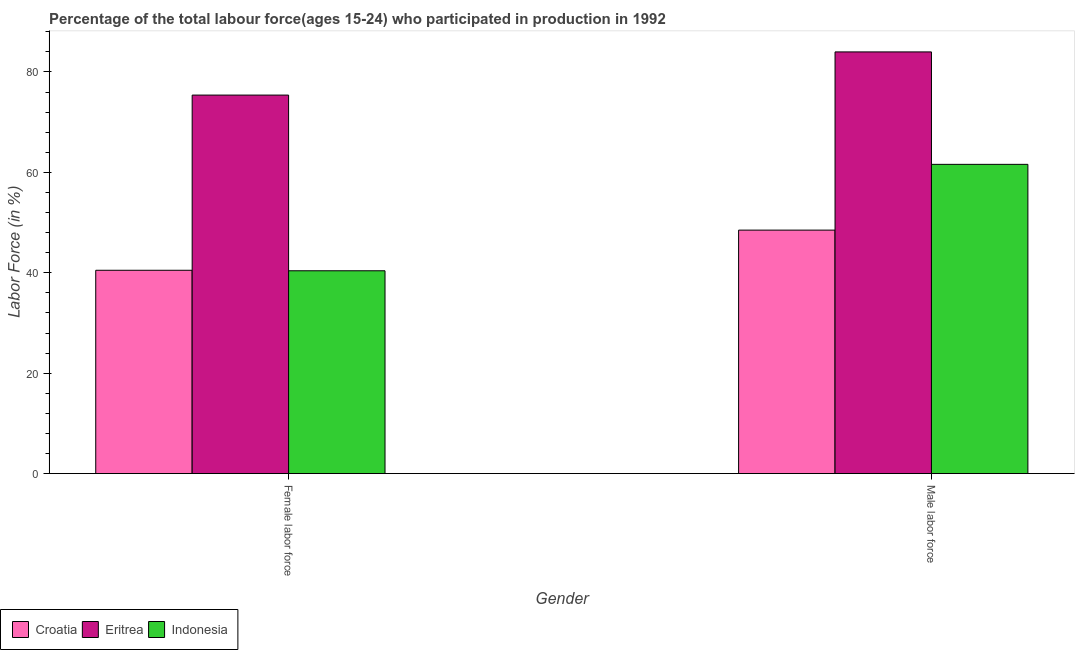How many different coloured bars are there?
Offer a terse response. 3. How many groups of bars are there?
Your answer should be compact. 2. Are the number of bars on each tick of the X-axis equal?
Provide a short and direct response. Yes. How many bars are there on the 2nd tick from the left?
Provide a short and direct response. 3. What is the label of the 1st group of bars from the left?
Provide a succinct answer. Female labor force. What is the percentage of female labor force in Eritrea?
Make the answer very short. 75.4. Across all countries, what is the minimum percentage of female labor force?
Give a very brief answer. 40.4. In which country was the percentage of male labour force maximum?
Give a very brief answer. Eritrea. In which country was the percentage of male labour force minimum?
Make the answer very short. Croatia. What is the total percentage of female labor force in the graph?
Ensure brevity in your answer.  156.3. What is the difference between the percentage of male labour force in Croatia and that in Eritrea?
Offer a very short reply. -35.5. What is the difference between the percentage of female labor force in Eritrea and the percentage of male labour force in Croatia?
Offer a terse response. 26.9. What is the average percentage of female labor force per country?
Provide a short and direct response. 52.1. What is the difference between the percentage of female labor force and percentage of male labour force in Indonesia?
Keep it short and to the point. -21.2. What is the ratio of the percentage of male labour force in Croatia to that in Indonesia?
Offer a terse response. 0.79. Is the percentage of female labor force in Croatia less than that in Indonesia?
Ensure brevity in your answer.  No. In how many countries, is the percentage of female labor force greater than the average percentage of female labor force taken over all countries?
Provide a succinct answer. 1. What does the 2nd bar from the left in Male labor force represents?
Provide a succinct answer. Eritrea. What does the 3rd bar from the right in Female labor force represents?
Make the answer very short. Croatia. How many countries are there in the graph?
Your answer should be very brief. 3. What is the difference between two consecutive major ticks on the Y-axis?
Offer a very short reply. 20. Does the graph contain grids?
Make the answer very short. No. How many legend labels are there?
Make the answer very short. 3. How are the legend labels stacked?
Your answer should be compact. Horizontal. What is the title of the graph?
Your response must be concise. Percentage of the total labour force(ages 15-24) who participated in production in 1992. Does "South Asia" appear as one of the legend labels in the graph?
Provide a succinct answer. No. What is the label or title of the X-axis?
Give a very brief answer. Gender. What is the label or title of the Y-axis?
Keep it short and to the point. Labor Force (in %). What is the Labor Force (in %) in Croatia in Female labor force?
Give a very brief answer. 40.5. What is the Labor Force (in %) of Eritrea in Female labor force?
Your answer should be compact. 75.4. What is the Labor Force (in %) in Indonesia in Female labor force?
Provide a succinct answer. 40.4. What is the Labor Force (in %) in Croatia in Male labor force?
Your answer should be compact. 48.5. What is the Labor Force (in %) of Indonesia in Male labor force?
Offer a terse response. 61.6. Across all Gender, what is the maximum Labor Force (in %) of Croatia?
Your response must be concise. 48.5. Across all Gender, what is the maximum Labor Force (in %) in Indonesia?
Your response must be concise. 61.6. Across all Gender, what is the minimum Labor Force (in %) of Croatia?
Provide a short and direct response. 40.5. Across all Gender, what is the minimum Labor Force (in %) in Eritrea?
Make the answer very short. 75.4. Across all Gender, what is the minimum Labor Force (in %) of Indonesia?
Offer a terse response. 40.4. What is the total Labor Force (in %) in Croatia in the graph?
Make the answer very short. 89. What is the total Labor Force (in %) of Eritrea in the graph?
Keep it short and to the point. 159.4. What is the total Labor Force (in %) of Indonesia in the graph?
Keep it short and to the point. 102. What is the difference between the Labor Force (in %) of Indonesia in Female labor force and that in Male labor force?
Make the answer very short. -21.2. What is the difference between the Labor Force (in %) in Croatia in Female labor force and the Labor Force (in %) in Eritrea in Male labor force?
Ensure brevity in your answer.  -43.5. What is the difference between the Labor Force (in %) in Croatia in Female labor force and the Labor Force (in %) in Indonesia in Male labor force?
Offer a very short reply. -21.1. What is the average Labor Force (in %) of Croatia per Gender?
Provide a short and direct response. 44.5. What is the average Labor Force (in %) of Eritrea per Gender?
Offer a terse response. 79.7. What is the difference between the Labor Force (in %) of Croatia and Labor Force (in %) of Eritrea in Female labor force?
Provide a short and direct response. -34.9. What is the difference between the Labor Force (in %) in Croatia and Labor Force (in %) in Eritrea in Male labor force?
Your answer should be very brief. -35.5. What is the difference between the Labor Force (in %) of Croatia and Labor Force (in %) of Indonesia in Male labor force?
Make the answer very short. -13.1. What is the difference between the Labor Force (in %) in Eritrea and Labor Force (in %) in Indonesia in Male labor force?
Provide a succinct answer. 22.4. What is the ratio of the Labor Force (in %) in Croatia in Female labor force to that in Male labor force?
Your answer should be very brief. 0.84. What is the ratio of the Labor Force (in %) of Eritrea in Female labor force to that in Male labor force?
Offer a terse response. 0.9. What is the ratio of the Labor Force (in %) of Indonesia in Female labor force to that in Male labor force?
Your answer should be compact. 0.66. What is the difference between the highest and the second highest Labor Force (in %) in Indonesia?
Give a very brief answer. 21.2. What is the difference between the highest and the lowest Labor Force (in %) in Eritrea?
Your answer should be compact. 8.6. What is the difference between the highest and the lowest Labor Force (in %) of Indonesia?
Make the answer very short. 21.2. 